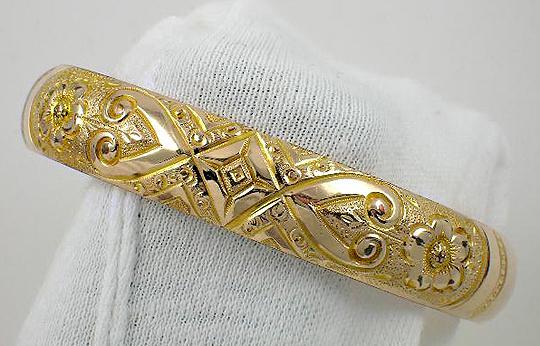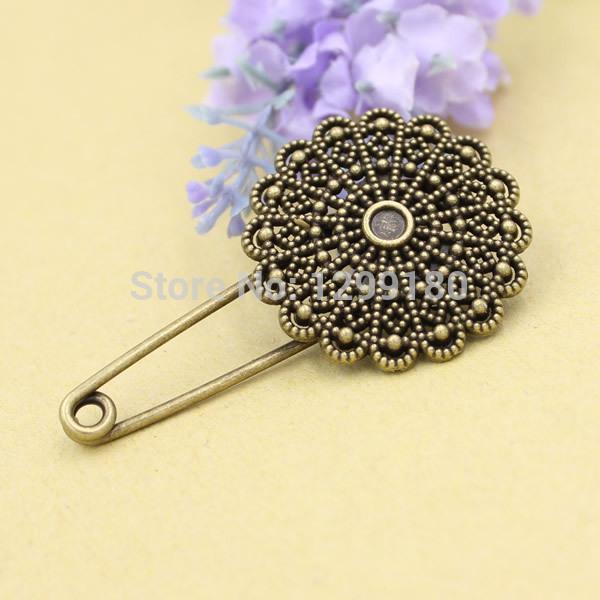The first image is the image on the left, the second image is the image on the right. Examine the images to the left and right. Is the description "The image to the left has a fabric background." accurate? Answer yes or no. Yes. 